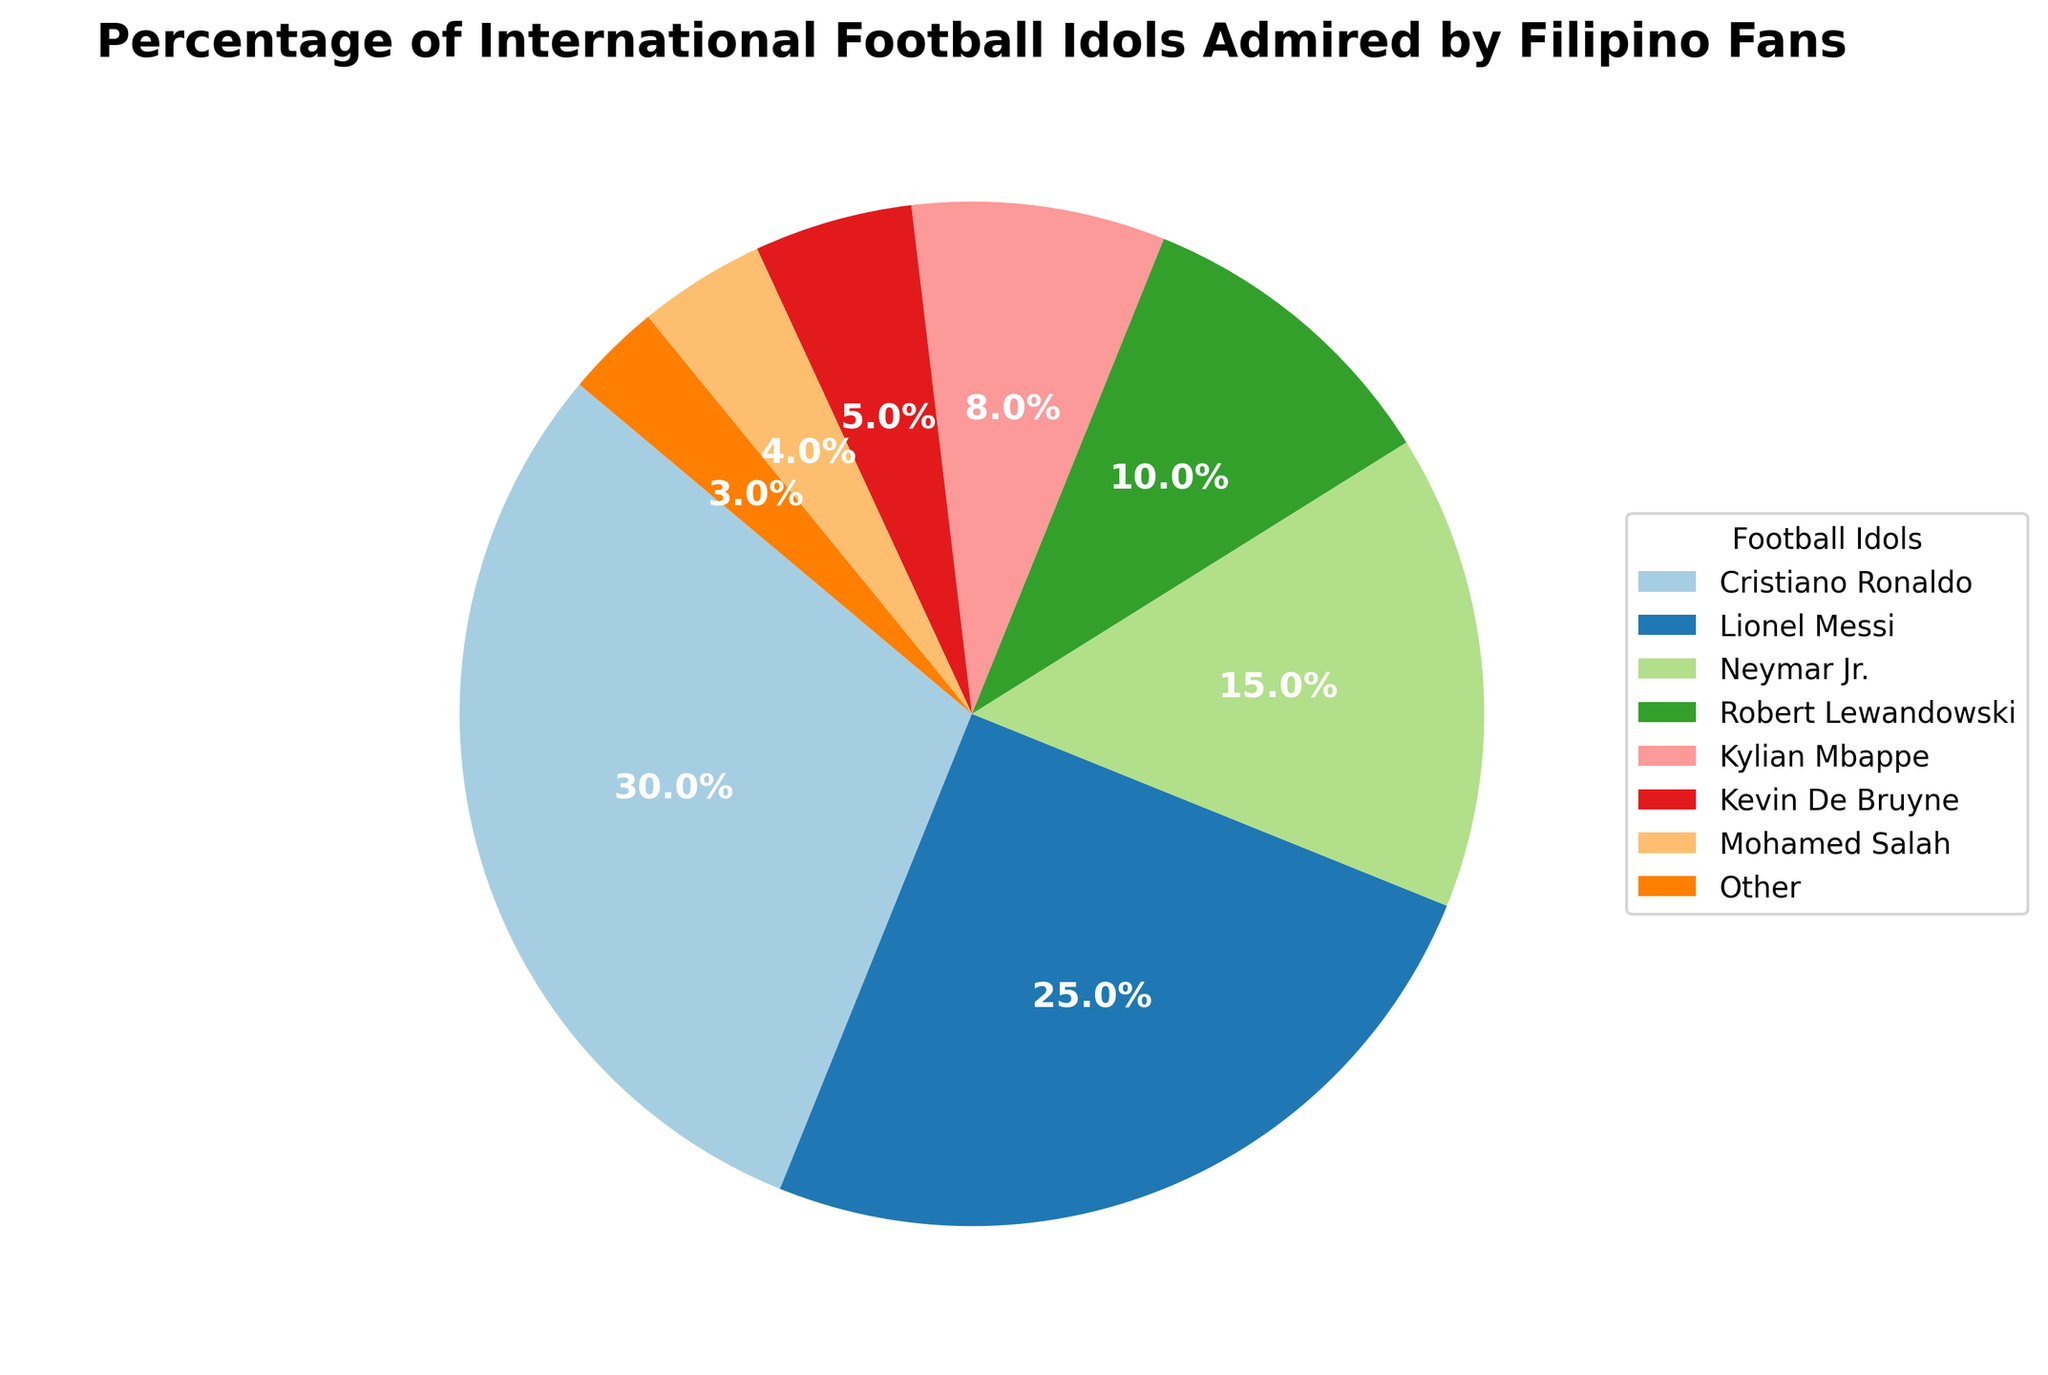Which international football idol is most admired by Filipino fans? The chart shows that the largest slice of the pie chart is labeled "Cristiano Ronaldo".
Answer: Cristiano Ronaldo Which two idols have the closest percentage of admiration? By looking at the slices and their percentages, Lionel Messi has 25% and Neymar Jr. has 15%, which are not the closest. The closest percentages are Kylian Mbappe and Kevin De Bruyne with 8% and 5% respectively.
Answer: Kylian Mbappe and Kevin De Bruyne What is the combined admiration percentage for Lionel Messi and Neymar Jr.? Add the percentages for Lionel Messi (25%) and Neymar Jr. (15%).
Answer: 40% Which idol has the least percentage of admiration? The smallest slice of the pie chart is labeled "Other" with 3%.
Answer: Other How does the admiration percentage of Mohamed Salah compare to that of Robert Lewandowski? Mohamed Salah has 4% while Robert Lewandowski has 10%. 4% is less than 10%.
Answer: Mohamed Salah has a lower percentage What percentage of admiration is shared by Kylian Mbappe, Kevin De Bruyne, and Mohamed Salah? Add the percentages: Kylian Mbappe (8%), Kevin De Bruyne (5%), and Mohamed Salah (4%). 8% + 5% + 4% = 17%.
Answer: 17% Which of the idols has a larger slice than Neymar Jr. but smaller than Lionel Messi? Neymar Jr. has 15% and Lionel Messi has 25%. Cristiano Ronaldo has the largest slice at 30%, which is excluded. Robert Lewandowski is next at 10%, which does not fall into the range, so no idol fits the criterion.
Answer: None How much larger is Cristiano Ronaldo’s admiration percentage compared to Robert Lewandowski's? Cristiano Ronaldo has 30% and Robert Lewandowski has 10%. Subtract 10% from 30% to find the difference.
Answer: 20% What is the difference in admiration percentage between the idol with the highest and the idol with the lowest admiration? The highest admiration is for Cristiano Ronaldo at 30%, and the lowest is for "Other" at 3%. Subtract 3% from 30% to find the difference.
Answer: 27% 